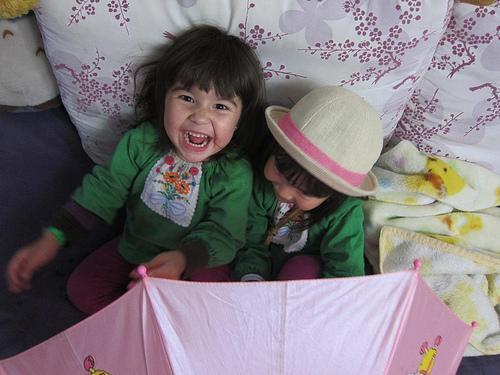How many children are there?
Give a very brief answer. 2. 